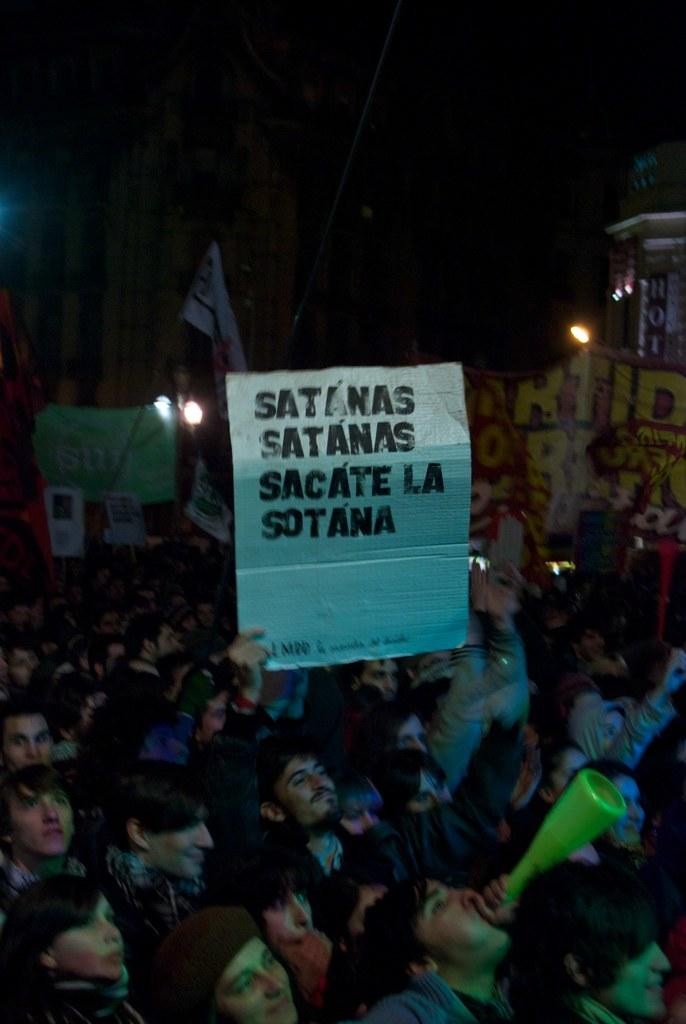What are the people in the image doing? There is a group of persons standing in the image, and they are holding a board. Can you describe the people in the background of the image? There are persons in the background of the image, but their actions are not clear from the provided facts. What can be seen in the background of the image? There is a flag, lights, and a house in the background of the image. What type of pocket can be seen on the flag in the image? There is no pocket visible on the flag in the image, as flags do not typically have pockets. 